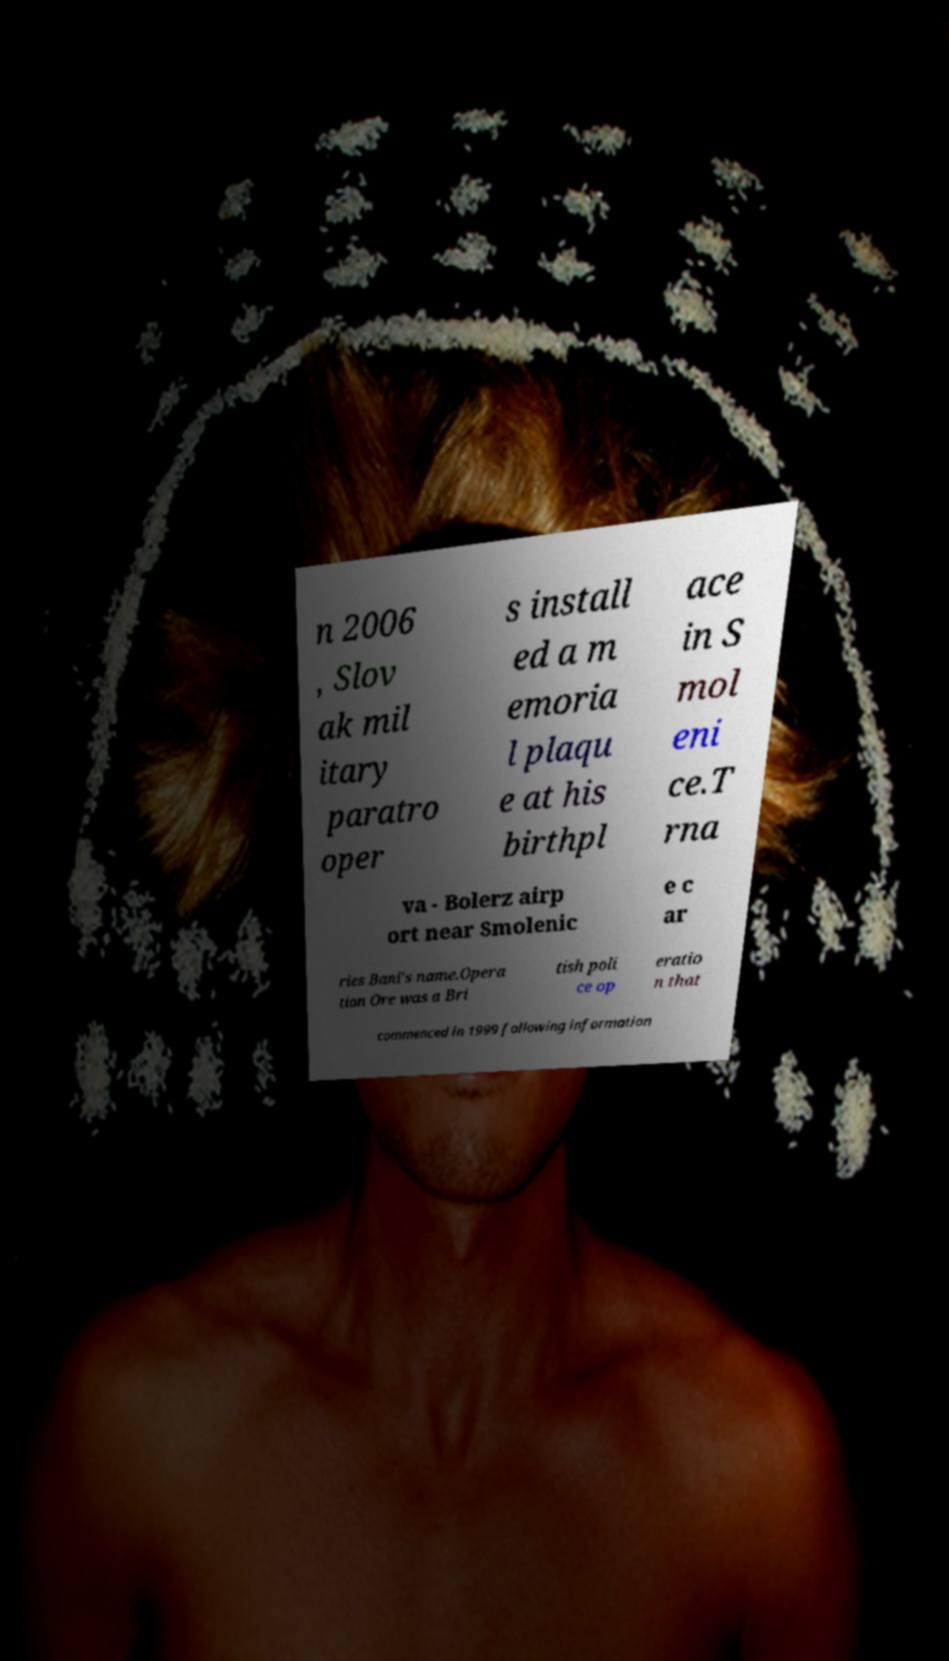Could you extract and type out the text from this image? n 2006 , Slov ak mil itary paratro oper s install ed a m emoria l plaqu e at his birthpl ace in S mol eni ce.T rna va - Bolerz airp ort near Smolenic e c ar ries Bani's name.Opera tion Ore was a Bri tish poli ce op eratio n that commenced in 1999 following information 